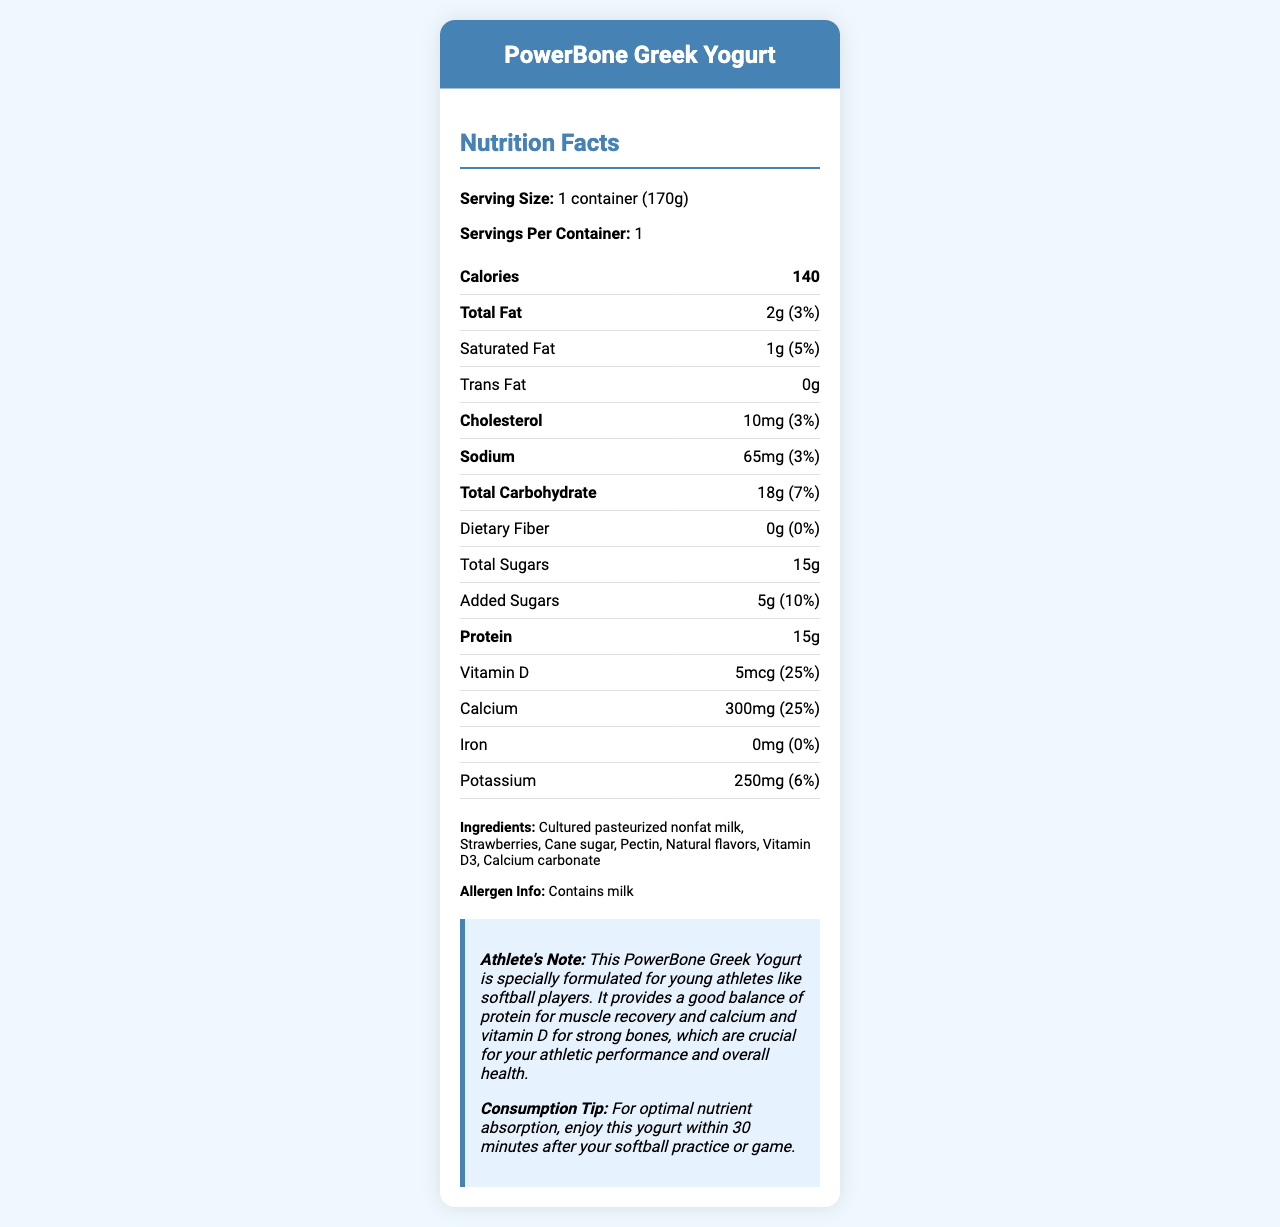what is the serving size of PowerBone Greek Yogurt? The serving size is clearly stated as "1 container (170g)" in the document.
Answer: 1 container (170g) what is the total protein content per serving? The document indicates that the protein content is 15g per serving.
Answer: 15g how much added sugar does this yogurt contain? The "Added Sugars" section of the document states that there are 5g of added sugars.
Answer: 5g what percentage of the daily value of calcium does one serving provide? The document lists calcium as providing 25% of the daily value per serving.
Answer: 25% what is the amount of Vitamin D in this yogurt? The document specifies that there is 5mcg of Vitamin D per serving.
Answer: 5mcg which ingredient is not present in the PowerBone Greek Yogurt? A. Pectin B. High Fructose Corn Syrup C. Cane Sugar The ingredients list includes Pectin and Cane Sugar but does not mention High Fructose Corn Syrup.
Answer: B what is the total fat content in this yogurt? A. 1g B. 2g C. 3g D. 0g According to the document, the total fat content is 2g.
Answer: B does this yogurt contain any dietary fiber? The document shows 0g of dietary fiber, indicating that it contains no dietary fiber.
Answer: No is there any cholesterol in this yogurt? The document states there is 10mg of cholesterol per serving, therefore, it contains cholesterol.
Answer: Yes summarize the main nutritional benefits provided by PowerBone Greek Yogurt for a young athlete. The document emphasizes that the yogurt offers protein for muscle recovery, calcium, and Vitamin D for bone health, which are important for athletic performance. It also contains supporting facts about its nutritional content, like low total fat and total calories.
Answer: PowerBone Greek Yogurt is a well-balanced snack providing significant protein for muscle recovery and high levels of calcium and Vitamin D for strong bones, essential for young athletes. Additionally, it contains low total fat and calories, making it a healthy option for maintaining energy levels post-practice or game. how many containers are there per serving? The document specifies the serving size and the servings per container but does not elaborate on the number of containers per serving. Likely, this question is misphrased, and the answer is not clear from the given document.
Answer: Not enough information what is the suggested consumption time for optimal nutrient absorption? The document provides a consumption tip that suggests enjoying the yogurt within 30 minutes after practice or a game for optimal nutrient absorption.
Answer: within 30 minutes after your softball practice or game which ingredient provides additional Vitamin D in this yogurt? Among the listed ingredients, Vitamin D3 is the one providing additional Vitamin D.
Answer: Vitamin D3 is it safe for someone with a milk allergy to consume this yogurt? The allergen information clearly states that the yogurt contains milk, making it unsuitable for someone with a milk allergy.
Answer: No 